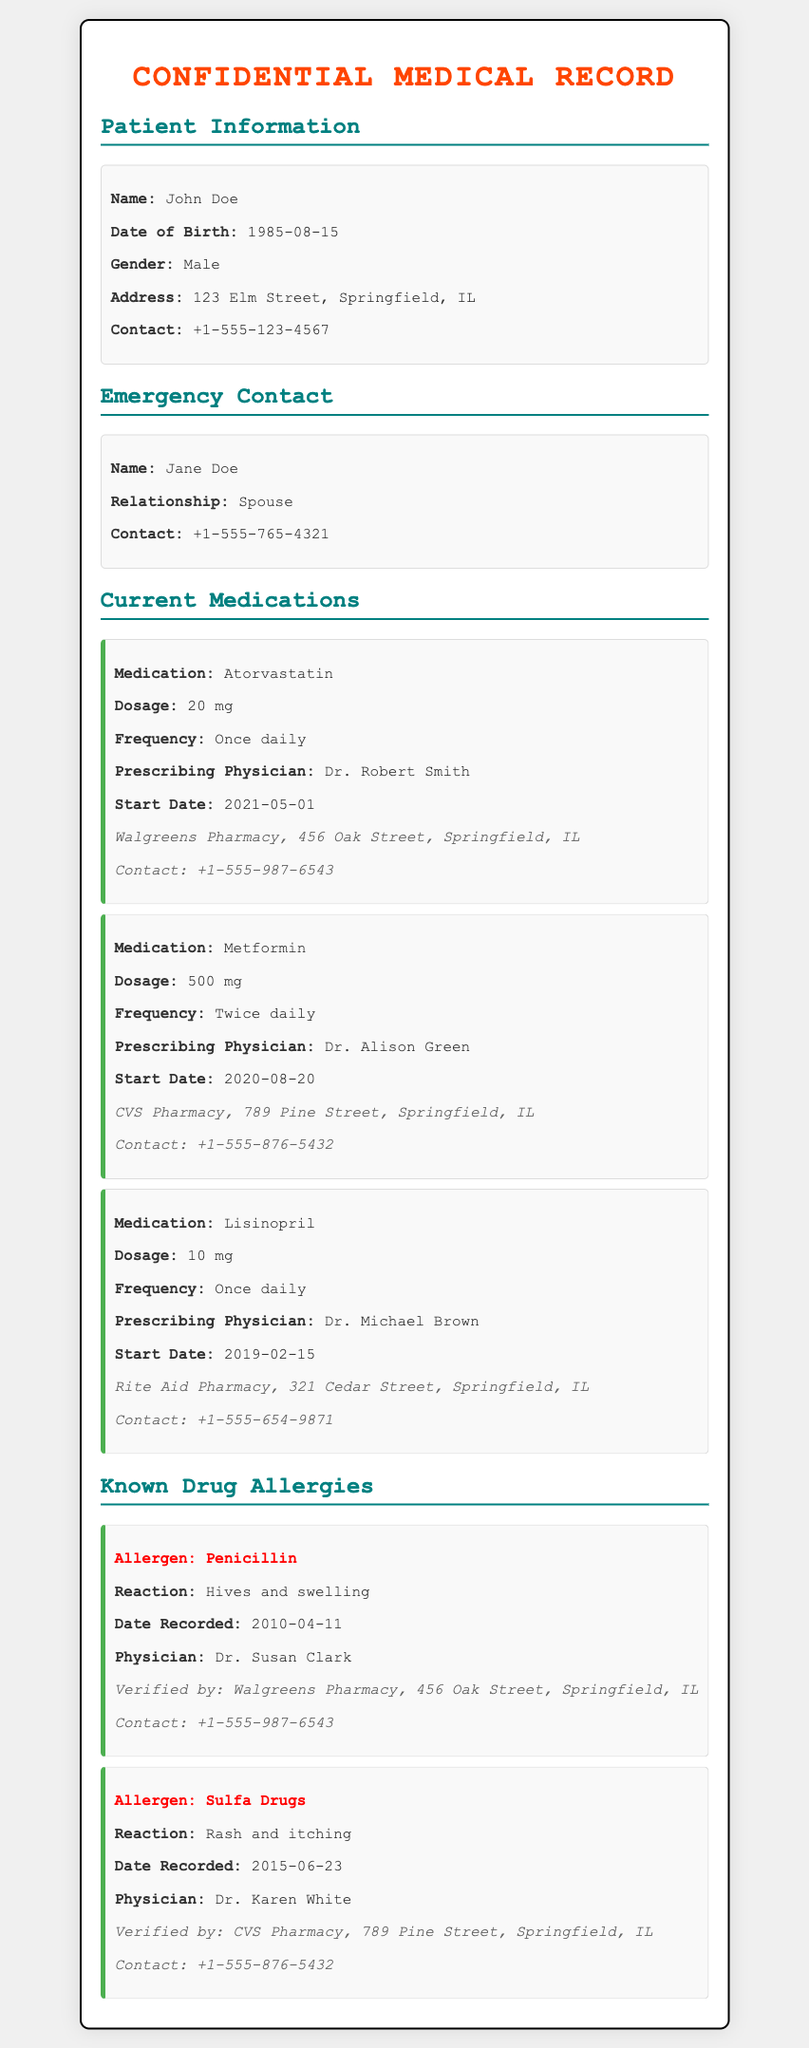What is the name of the patient? The name of the patient is listed under Patient Information.
Answer: John Doe What is the dosage of Metformin? The dosage of Metformin is specified in the Current Medications section.
Answer: 500 mg What is the contact number for Walgreens Pharmacy? The contact number can be found in the medication information for Atorvastatin.
Answer: +1-555-987-6543 What is the reaction to Penicillin? The reaction to Penicillin is recorded under Known Drug Allergies.
Answer: Hives and swelling Who is the prescribing physician for Lisinopril? The physician's name is mentioned in the Current Medications section.
Answer: Dr. Michael Brown Which pharmacy verified the allergy to Sulfa Drugs? The pharmacy is indicated in the Known Drug Allergies section.
Answer: CVS Pharmacy When was the allergy to Penicillin recorded? The date is provided in the Known Drug Allergies section.
Answer: 2010-04-11 What is the frequency of Atorvastatin intake? The frequency is specified in the Current Medications details.
Answer: Once daily Which emergency contact is listed? The name of the emergency contact is found in the Emergency Contact section.
Answer: Jane Doe 